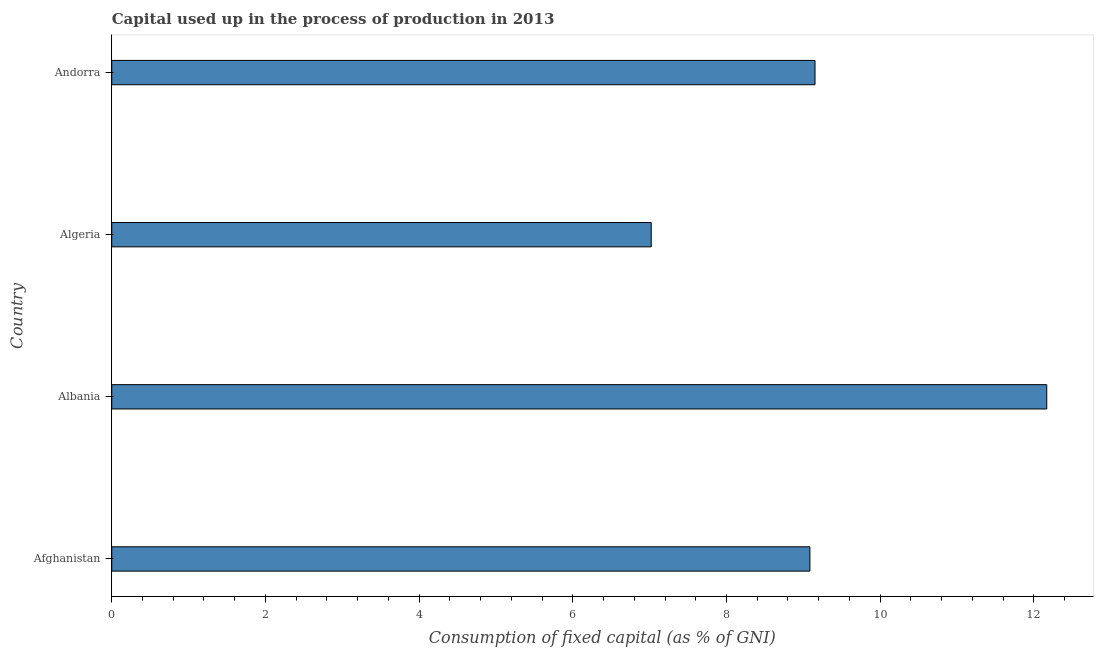Does the graph contain any zero values?
Your answer should be very brief. No. What is the title of the graph?
Ensure brevity in your answer.  Capital used up in the process of production in 2013. What is the label or title of the X-axis?
Offer a very short reply. Consumption of fixed capital (as % of GNI). What is the label or title of the Y-axis?
Your answer should be compact. Country. What is the consumption of fixed capital in Albania?
Provide a short and direct response. 12.17. Across all countries, what is the maximum consumption of fixed capital?
Offer a terse response. 12.17. Across all countries, what is the minimum consumption of fixed capital?
Make the answer very short. 7.02. In which country was the consumption of fixed capital maximum?
Your response must be concise. Albania. In which country was the consumption of fixed capital minimum?
Your answer should be very brief. Algeria. What is the sum of the consumption of fixed capital?
Provide a succinct answer. 37.43. What is the difference between the consumption of fixed capital in Albania and Algeria?
Keep it short and to the point. 5.15. What is the average consumption of fixed capital per country?
Make the answer very short. 9.36. What is the median consumption of fixed capital?
Keep it short and to the point. 9.12. In how many countries, is the consumption of fixed capital greater than 1.6 %?
Your answer should be compact. 4. What is the ratio of the consumption of fixed capital in Albania to that in Algeria?
Your answer should be compact. 1.73. Is the consumption of fixed capital in Afghanistan less than that in Andorra?
Offer a very short reply. Yes. What is the difference between the highest and the second highest consumption of fixed capital?
Offer a very short reply. 3.02. What is the difference between the highest and the lowest consumption of fixed capital?
Keep it short and to the point. 5.15. In how many countries, is the consumption of fixed capital greater than the average consumption of fixed capital taken over all countries?
Make the answer very short. 1. How many bars are there?
Make the answer very short. 4. Are all the bars in the graph horizontal?
Keep it short and to the point. Yes. How many countries are there in the graph?
Provide a short and direct response. 4. What is the Consumption of fixed capital (as % of GNI) in Afghanistan?
Offer a terse response. 9.09. What is the Consumption of fixed capital (as % of GNI) of Albania?
Give a very brief answer. 12.17. What is the Consumption of fixed capital (as % of GNI) in Algeria?
Give a very brief answer. 7.02. What is the Consumption of fixed capital (as % of GNI) in Andorra?
Your answer should be compact. 9.15. What is the difference between the Consumption of fixed capital (as % of GNI) in Afghanistan and Albania?
Your answer should be compact. -3.08. What is the difference between the Consumption of fixed capital (as % of GNI) in Afghanistan and Algeria?
Ensure brevity in your answer.  2.06. What is the difference between the Consumption of fixed capital (as % of GNI) in Afghanistan and Andorra?
Provide a succinct answer. -0.07. What is the difference between the Consumption of fixed capital (as % of GNI) in Albania and Algeria?
Your response must be concise. 5.15. What is the difference between the Consumption of fixed capital (as % of GNI) in Albania and Andorra?
Ensure brevity in your answer.  3.02. What is the difference between the Consumption of fixed capital (as % of GNI) in Algeria and Andorra?
Your answer should be compact. -2.13. What is the ratio of the Consumption of fixed capital (as % of GNI) in Afghanistan to that in Albania?
Provide a succinct answer. 0.75. What is the ratio of the Consumption of fixed capital (as % of GNI) in Afghanistan to that in Algeria?
Keep it short and to the point. 1.29. What is the ratio of the Consumption of fixed capital (as % of GNI) in Albania to that in Algeria?
Your answer should be very brief. 1.73. What is the ratio of the Consumption of fixed capital (as % of GNI) in Albania to that in Andorra?
Your answer should be very brief. 1.33. What is the ratio of the Consumption of fixed capital (as % of GNI) in Algeria to that in Andorra?
Your answer should be very brief. 0.77. 